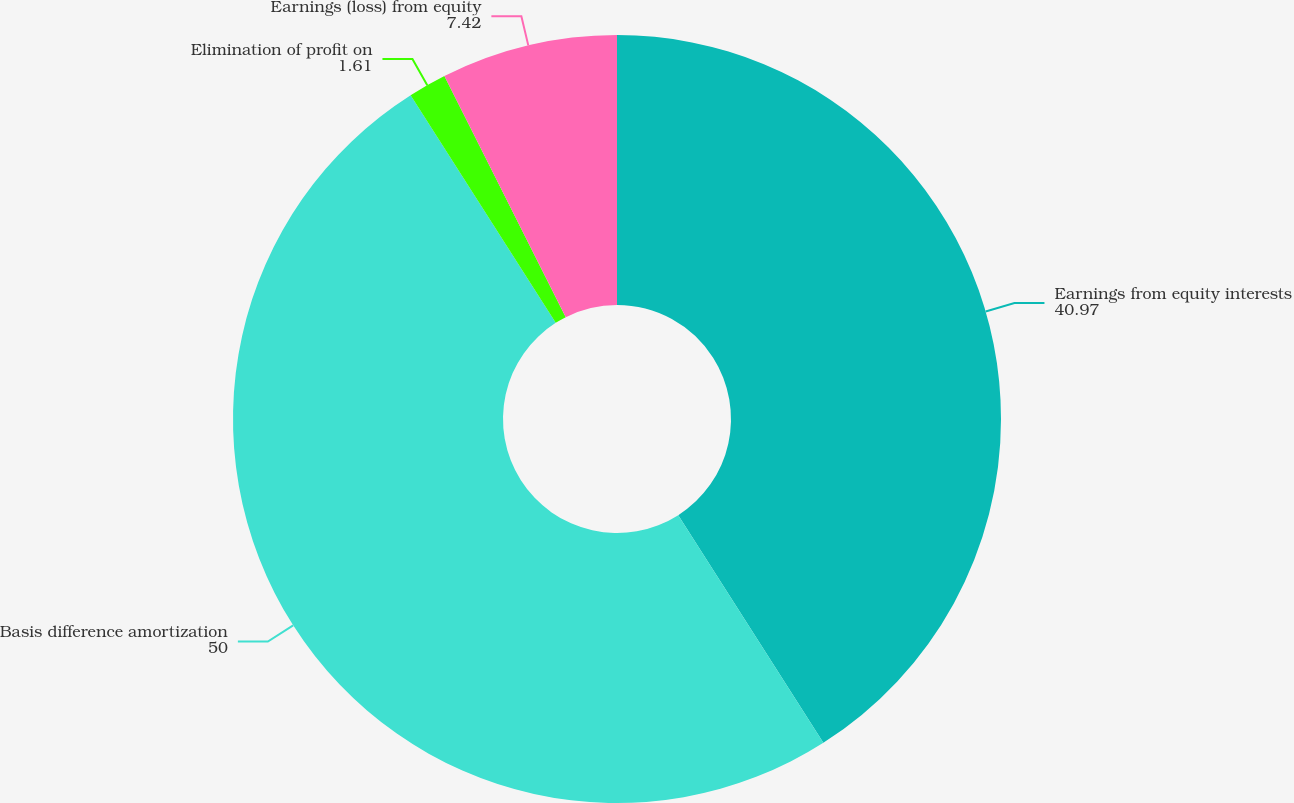Convert chart to OTSL. <chart><loc_0><loc_0><loc_500><loc_500><pie_chart><fcel>Earnings from equity interests<fcel>Basis difference amortization<fcel>Elimination of profit on<fcel>Earnings (loss) from equity<nl><fcel>40.97%<fcel>50.0%<fcel>1.61%<fcel>7.42%<nl></chart> 